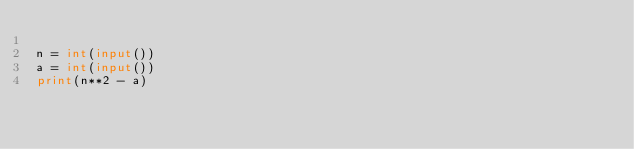<code> <loc_0><loc_0><loc_500><loc_500><_Python_>
n = int(input())
a = int(input())
print(n**2 - a)
</code> 